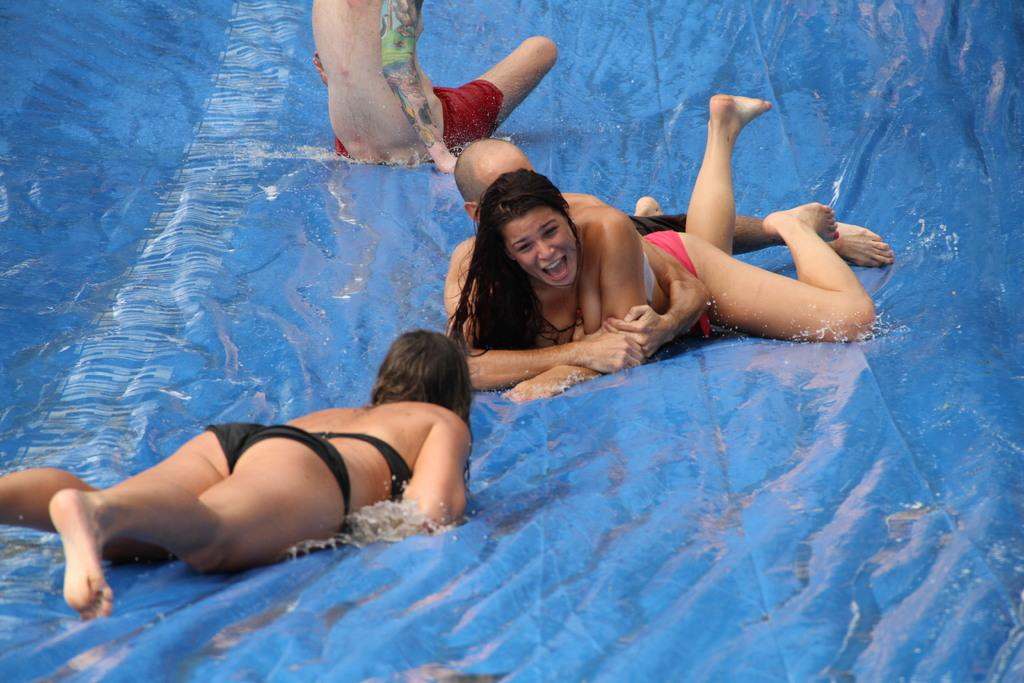What activity are the people engaged in within the image? The people are on a slide in the image. Can you describe the position of one of the individuals on the slide? A lady is sleeping on the slide. What is the lady wearing in the image? The lady is wearing a black bikini. What is the color of the slide's surface? The surface of the slide is blue in color. What type of soup is being served in the image? There is no soup present in the image; it features people on a slide. How many cherries can be seen on the slide in the image? There are no cherries present in the image; it only shows people on a slide. 